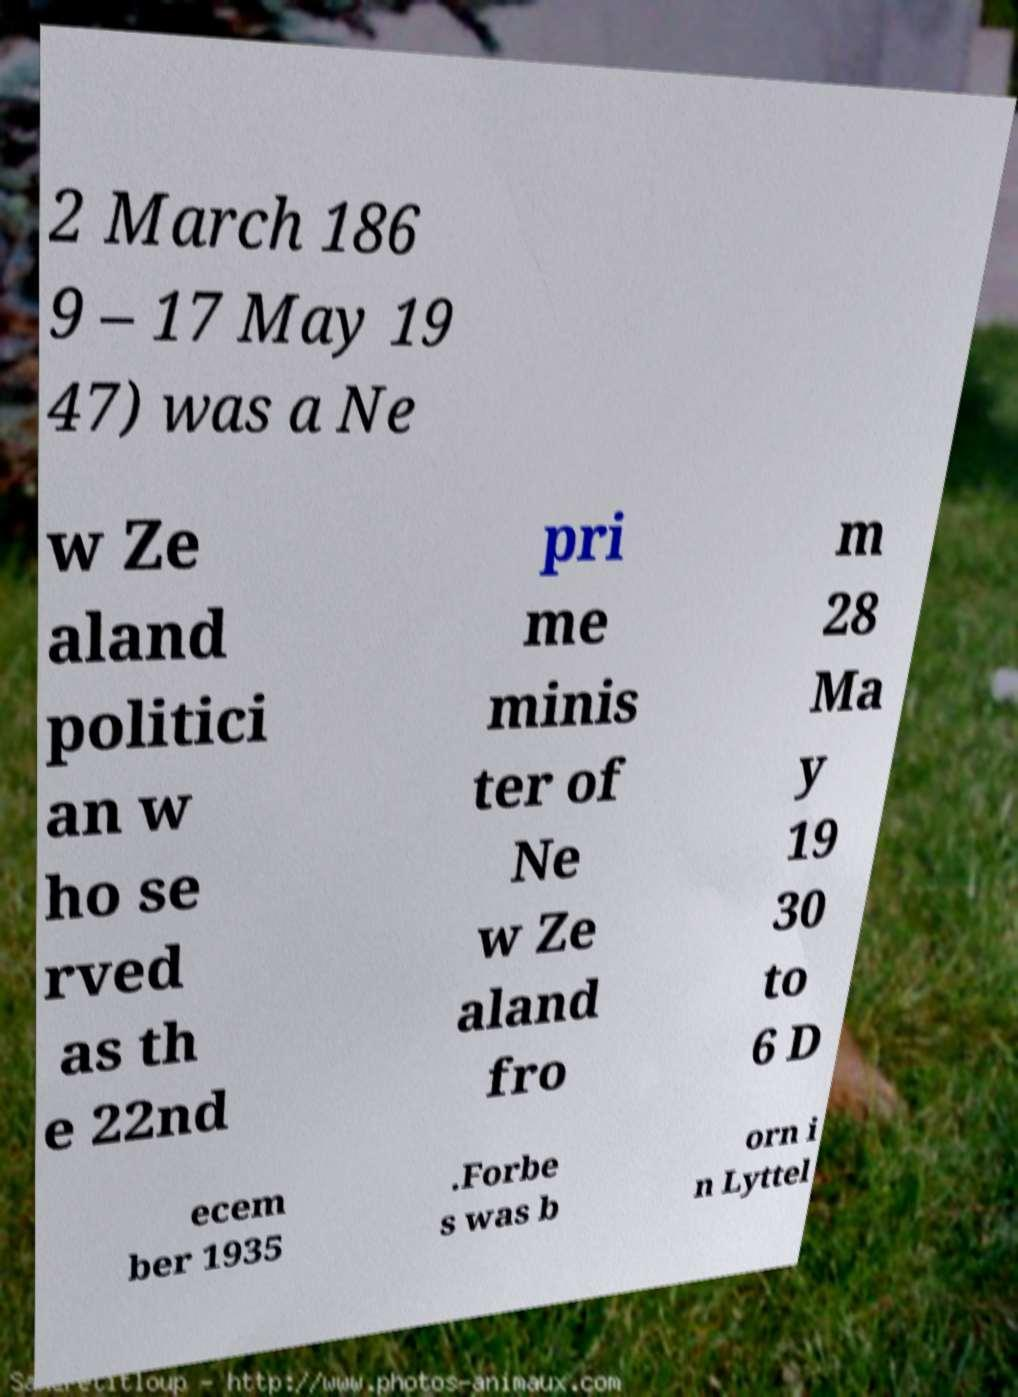Can you accurately transcribe the text from the provided image for me? 2 March 186 9 – 17 May 19 47) was a Ne w Ze aland politici an w ho se rved as th e 22nd pri me minis ter of Ne w Ze aland fro m 28 Ma y 19 30 to 6 D ecem ber 1935 .Forbe s was b orn i n Lyttel 